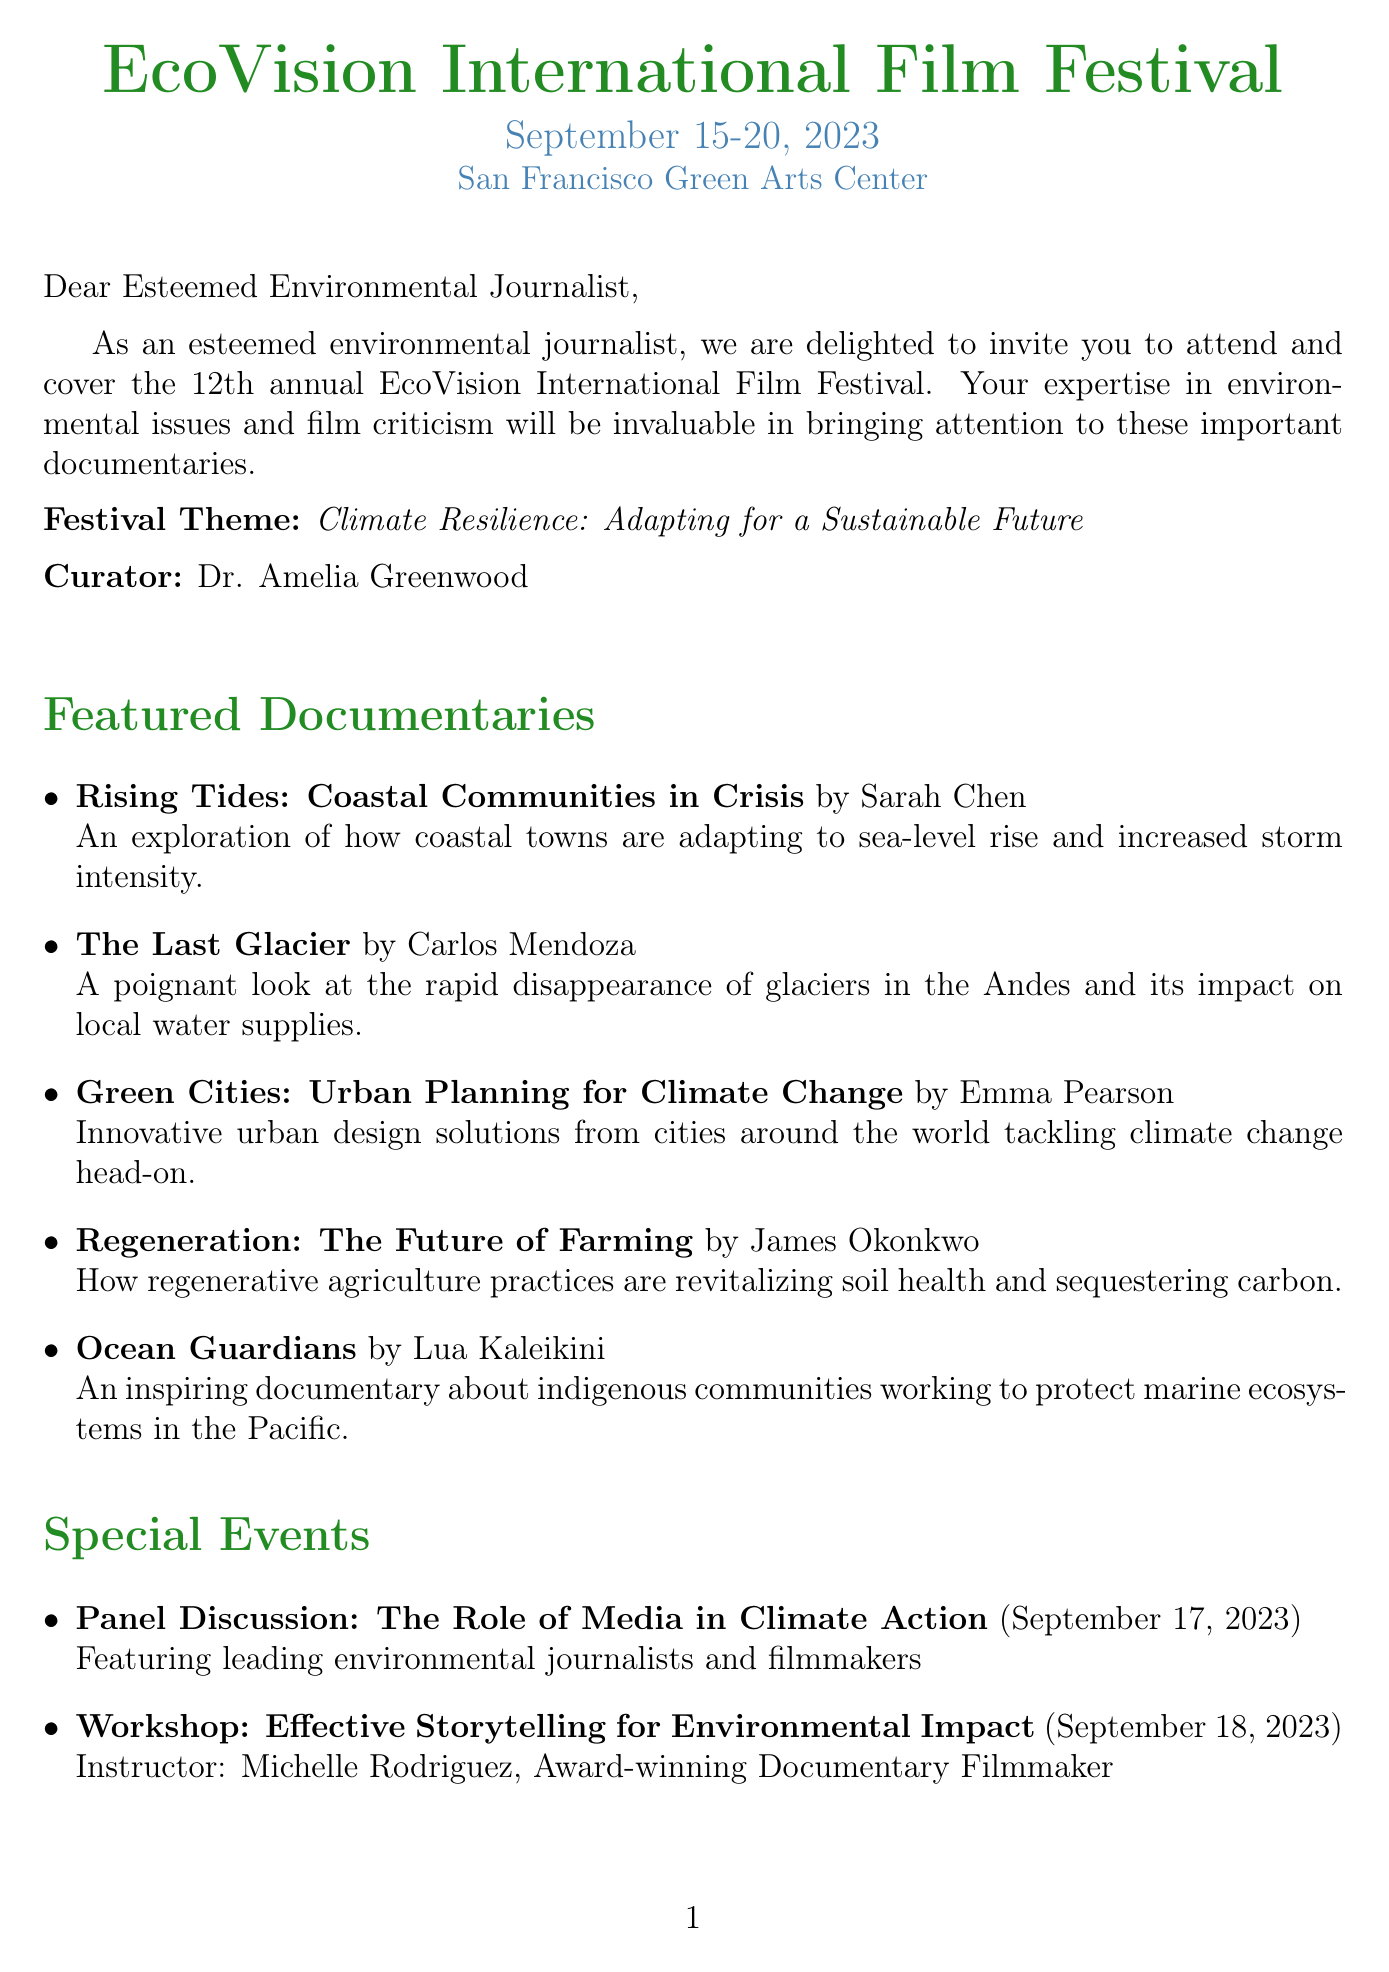What are the dates of the festival? The dates of the festival are clearly listed at the top of the document as September 15-20, 2023.
Answer: September 15-20, 2023 Who is the curator of the festival? The letter specifies the curator's name, which is mentioned as Dr. Amelia Greenwood.
Answer: Dr. Amelia Greenwood What is the theme of the festival? The theme is stated in the document as Climate Resilience: Adapting for a Sustainable Future.
Answer: Climate Resilience: Adapting for a Sustainable Future What is the accommodation offered? The document states that a complimentary stay at the eco-friendly Bay View Hotel is provided for attendees.
Answer: Bay View Hotel When is the RSVP deadline? The letter mentions the RSVP deadline, which is August 15, 2023.
Answer: August 15, 2023 Which documentary is directed by Sarah Chen? The letter lists Rising Tides: Coastal Communities in Crisis and attributes it to Sarah Chen.
Answer: Rising Tides: Coastal Communities in Crisis What is a special event during the festival? The document lists various special events, one of which is the Panel Discussion: The Role of Media in Climate Action.
Answer: Panel Discussion: The Role of Media in Climate Action What type of access do press members receive? The document mentions that press members enjoy full access to all screenings and Q&A sessions.
Answer: Full access to all screenings, Q&A sessions with directors, and exclusive interviews with featured filmmakers Who should be contacted for media relations? The letter provides a contact person for media relations as Lisa Thompson.
Answer: Lisa Thompson 